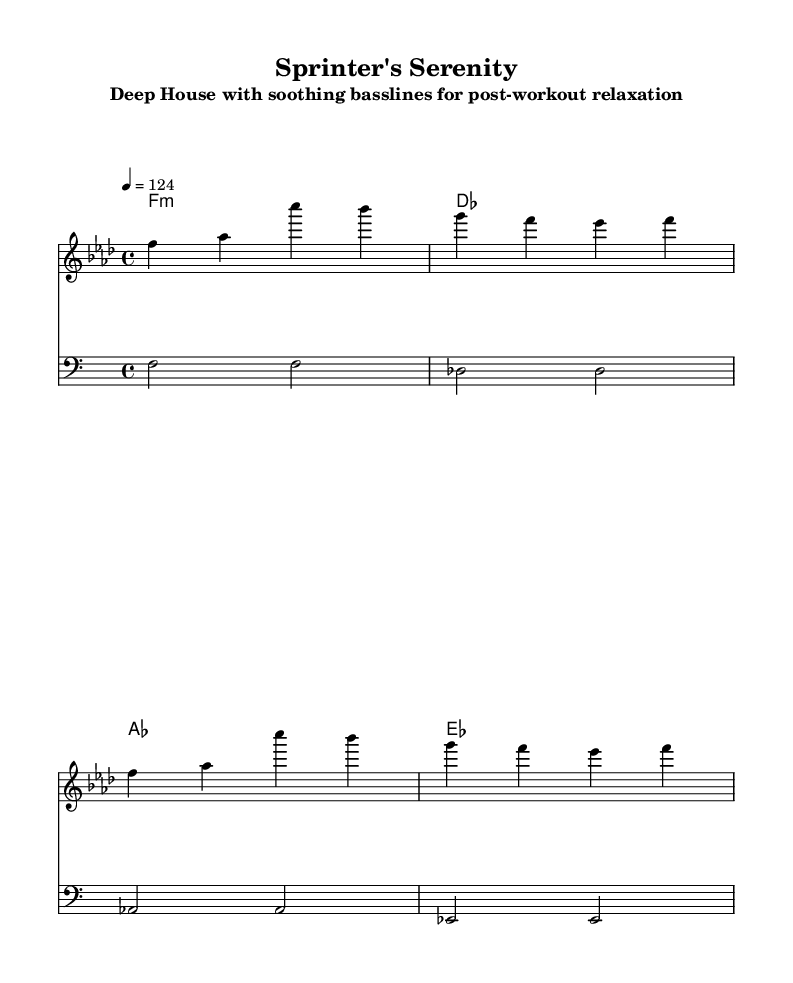What is the key signature of this music? The key signature is F minor, which has four flats. It is indicated at the beginning of the staff, showing that F is the tonic and flat signs relate to B, E, A, and D.
Answer: F minor What is the time signature of the piece? The time signature is shown as 4/4 at the beginning of the score, indicating that there are four beats in each measure and a quarter note receives one beat.
Answer: 4/4 What is the tempo marking for this piece? The tempo marking is noted as "4 = 124", meaning the piece should be played at a speed of 124 beats per minute, with each quarter note counting as one beat.
Answer: 124 How many measures are there in the melody? The melody consists of four measures, as indicated by the grouping of notes separated by vertical lines (bar lines), which denote the end of each measure.
Answer: 4 What type of chords are primarily used in the harmony section? The harmony section utilizes minor chords, as indicated by the "m" notation alongside the chord symbols such as F1:m, which indicates that the F chord is minor.
Answer: Minor What is the texture of the bassline in this piece? The bassline consists of sustained notes played in a lower register, contributing to the deep house style characterized by smooth, soothing basslines that provide a relaxed atmosphere.
Answer: Sustained deep bass Which notes are primarily used in the bassline? The bassline consists of the notes F, Des, As, and Es, which align with the harmony and create a cohesive sound throughout the piece.
Answer: F, Des, As, Es 